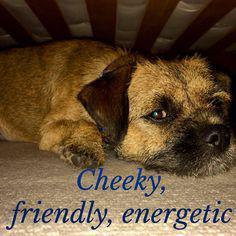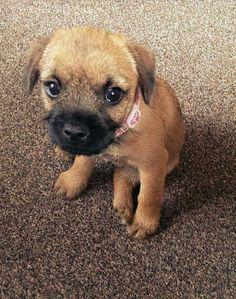The first image is the image on the left, the second image is the image on the right. Examine the images to the left and right. Is the description "The dog in the image on the right, he is not laying down." accurate? Answer yes or no. Yes. The first image is the image on the left, the second image is the image on the right. For the images shown, is this caption "the dog is laying down on the right side pic" true? Answer yes or no. No. 